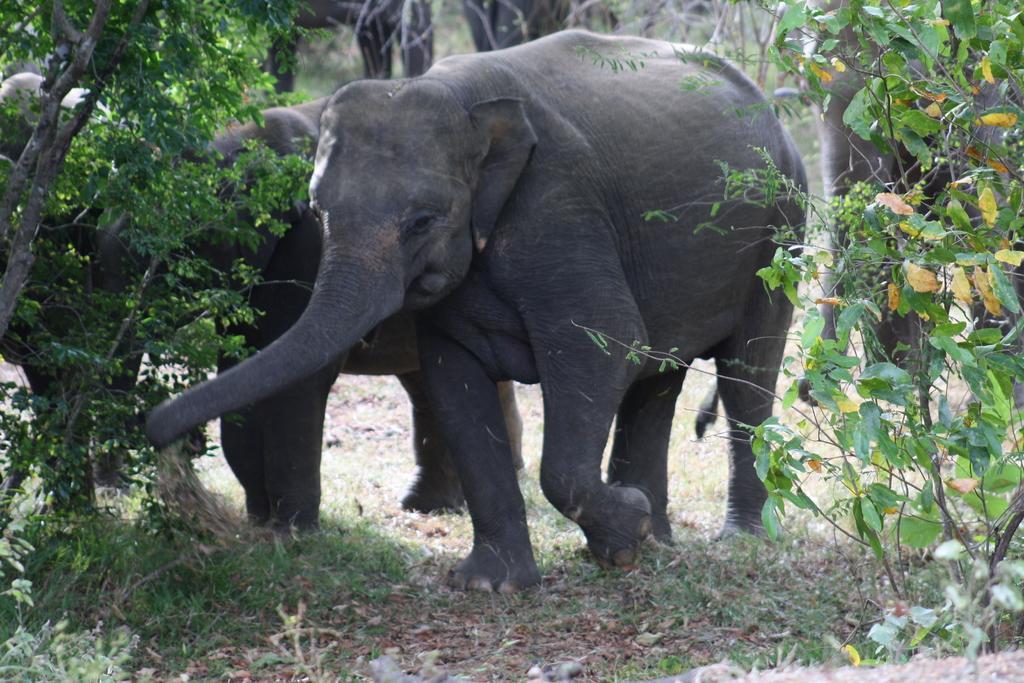Could you give a brief overview of what you see in this image? In this picture we can see elephants on the ground and in the background we can see trees. 